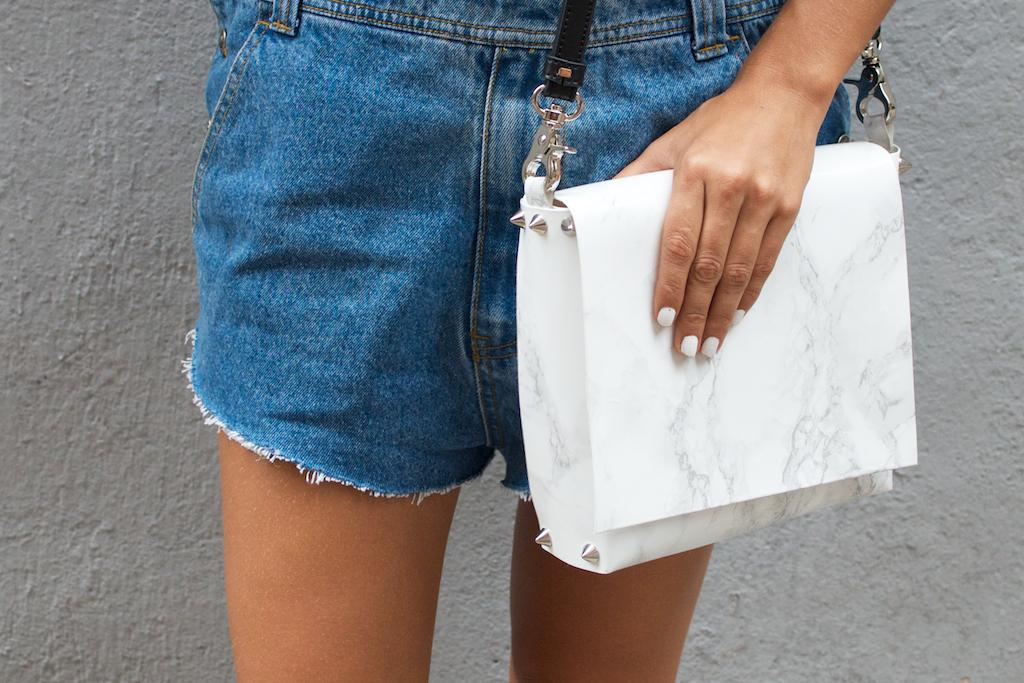What is present in the image? There is a person in the image. What type of clothing is the person wearing? The person is wearing blue jeans shorts. What object is the person holding? The person is holding a white wallet with a black strip. What can be seen in the background of the image? There is a grey color wall in the background of the image. Was there an earthquake in the image? There is no indication of an earthquake in the image. What type of sky is visible in the image? The provided facts do not mention the sky, so we cannot determine its type from the image. 